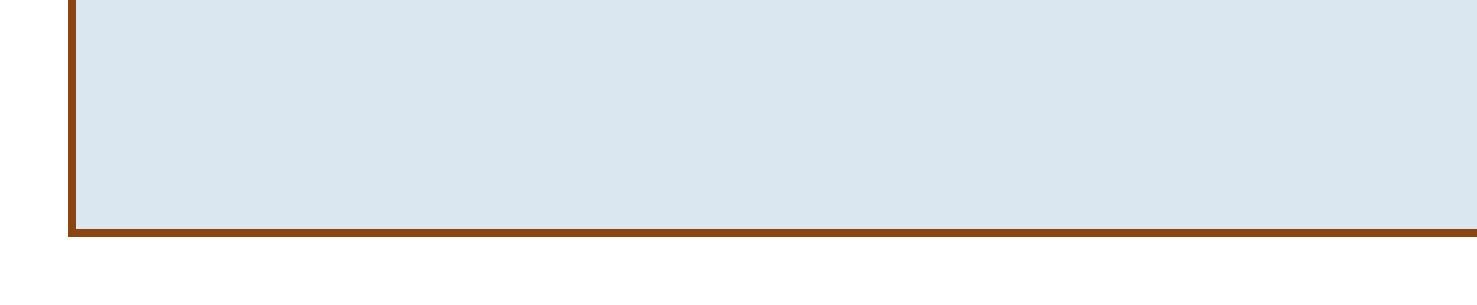What is the new chess rating achieved? The new chess rating is highlighted in the memo as the recently achieved milestone.
Answer: 2700 Who is the restaurant owner of Kasparov's Kitchen? The document specifies that the restaurant is owned by a former chess champion, providing a significant detail about its background.
Answer: Garry Kasparov What are the proposed dates for the celebratory dinner? The document clearly lists the dates being considered for the family celebration.
Answer: Saturday, May 20th and Sunday, May 21st What is one gift idea mentioned in the memo? The document offers various ideas for gifts, and one specific gift idea is listed among them.
Answer: Commemorative chess set What is one of the future goals mentioned? The document outlines several future objectives, requiring the reader to identify one.
Answer: Reaching 2750 rating What is the name of the local venue for community celebration? The memo details a venue for a community celebration, highlighting an important upcoming event.
Answer: Local Chess Club What relationship does John have to the author? The memo specifically refers to John in a familial context, clarifying his relationship to the author of the memo.
Answer: Brother What type of cuisine is offered at The Queen's Gambit? The memo categorizes restaurant options, including the type of food served at one particular restaurant.
Answer: Modern European 